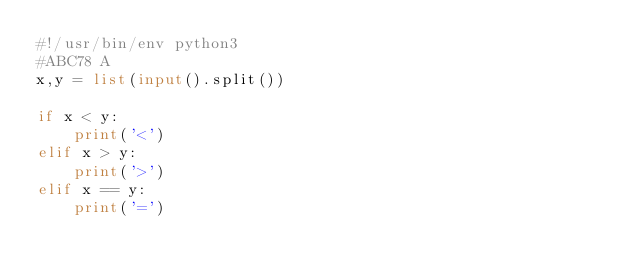Convert code to text. <code><loc_0><loc_0><loc_500><loc_500><_Python_>#!/usr/bin/env python3
#ABC78 A
x,y = list(input().split())

if x < y:
    print('<')
elif x > y:
    print('>')
elif x == y:
    print('=')
    
</code> 